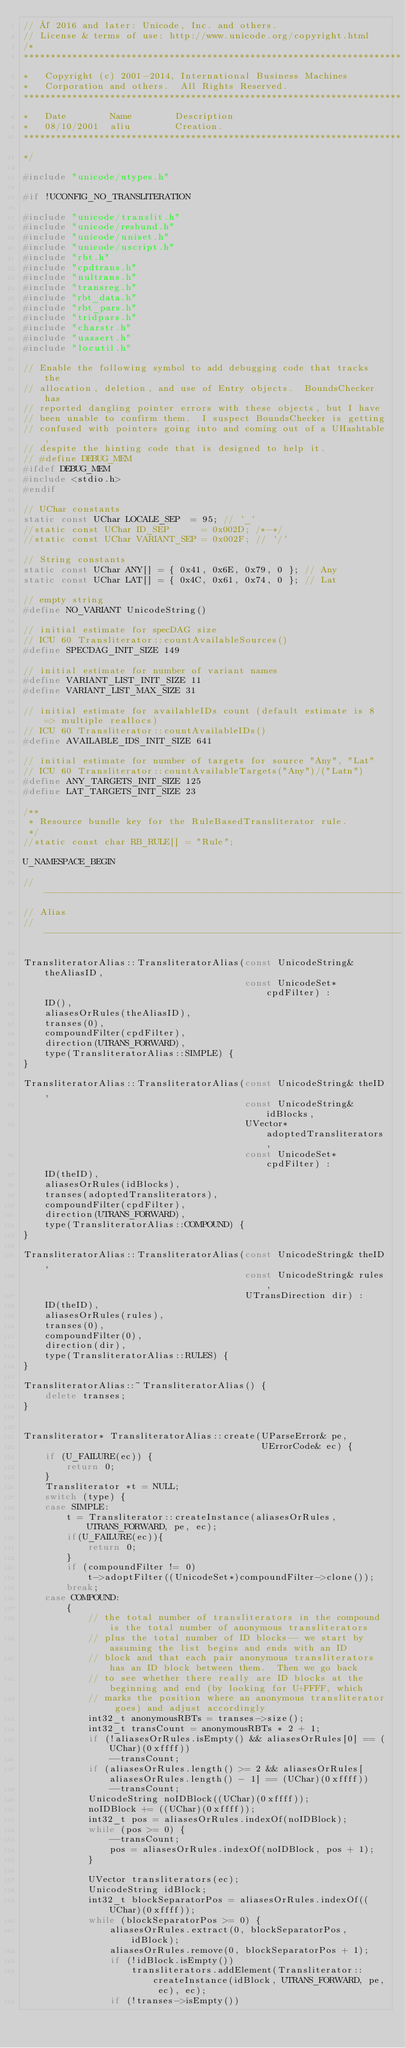Convert code to text. <code><loc_0><loc_0><loc_500><loc_500><_C++_>// © 2016 and later: Unicode, Inc. and others.
// License & terms of use: http://www.unicode.org/copyright.html
/*
**********************************************************************
*   Copyright (c) 2001-2014, International Business Machines
*   Corporation and others.  All Rights Reserved.
**********************************************************************
*   Date        Name        Description
*   08/10/2001  aliu        Creation.
**********************************************************************
*/

#include "unicode/utypes.h"

#if !UCONFIG_NO_TRANSLITERATION

#include "unicode/translit.h"
#include "unicode/resbund.h"
#include "unicode/uniset.h"
#include "unicode/uscript.h"
#include "rbt.h"
#include "cpdtrans.h"
#include "nultrans.h"
#include "transreg.h"
#include "rbt_data.h"
#include "rbt_pars.h"
#include "tridpars.h"
#include "charstr.h"
#include "uassert.h"
#include "locutil.h"

// Enable the following symbol to add debugging code that tracks the
// allocation, deletion, and use of Entry objects.  BoundsChecker has
// reported dangling pointer errors with these objects, but I have
// been unable to confirm them.  I suspect BoundsChecker is getting
// confused with pointers going into and coming out of a UHashtable,
// despite the hinting code that is designed to help it.
// #define DEBUG_MEM
#ifdef DEBUG_MEM
#include <stdio.h>
#endif

// UChar constants
static const UChar LOCALE_SEP  = 95; // '_'
//static const UChar ID_SEP      = 0x002D; /*-*/
//static const UChar VARIANT_SEP = 0x002F; // '/'

// String constants
static const UChar ANY[] = { 0x41, 0x6E, 0x79, 0 }; // Any
static const UChar LAT[] = { 0x4C, 0x61, 0x74, 0 }; // Lat

// empty string
#define NO_VARIANT UnicodeString()

// initial estimate for specDAG size
// ICU 60 Transliterator::countAvailableSources()
#define SPECDAG_INIT_SIZE 149

// initial estimate for number of variant names
#define VARIANT_LIST_INIT_SIZE 11
#define VARIANT_LIST_MAX_SIZE 31

// initial estimate for availableIDs count (default estimate is 8 => multiple reallocs)
// ICU 60 Transliterator::countAvailableIDs()
#define AVAILABLE_IDS_INIT_SIZE 641

// initial estimate for number of targets for source "Any", "Lat"
// ICU 60 Transliterator::countAvailableTargets("Any")/("Latn")
#define ANY_TARGETS_INIT_SIZE 125
#define LAT_TARGETS_INIT_SIZE 23

/**
 * Resource bundle key for the RuleBasedTransliterator rule.
 */
//static const char RB_RULE[] = "Rule";

U_NAMESPACE_BEGIN

//------------------------------------------------------------------
// Alias
//------------------------------------------------------------------

TransliteratorAlias::TransliteratorAlias(const UnicodeString& theAliasID,
                                         const UnicodeSet* cpdFilter) :
    ID(),
    aliasesOrRules(theAliasID),
    transes(0),
    compoundFilter(cpdFilter),
    direction(UTRANS_FORWARD),
    type(TransliteratorAlias::SIMPLE) {
}

TransliteratorAlias::TransliteratorAlias(const UnicodeString& theID,
                                         const UnicodeString& idBlocks,
                                         UVector* adoptedTransliterators,
                                         const UnicodeSet* cpdFilter) :
    ID(theID),
    aliasesOrRules(idBlocks),
    transes(adoptedTransliterators),
    compoundFilter(cpdFilter),
    direction(UTRANS_FORWARD),
    type(TransliteratorAlias::COMPOUND) {
}

TransliteratorAlias::TransliteratorAlias(const UnicodeString& theID,
                                         const UnicodeString& rules,
                                         UTransDirection dir) :
    ID(theID),
    aliasesOrRules(rules),
    transes(0),
    compoundFilter(0),
    direction(dir),
    type(TransliteratorAlias::RULES) {
}

TransliteratorAlias::~TransliteratorAlias() {
    delete transes;
}


Transliterator* TransliteratorAlias::create(UParseError& pe,
                                            UErrorCode& ec) {
    if (U_FAILURE(ec)) {
        return 0;
    }
    Transliterator *t = NULL;
    switch (type) {
    case SIMPLE:
        t = Transliterator::createInstance(aliasesOrRules, UTRANS_FORWARD, pe, ec);
        if(U_FAILURE(ec)){
            return 0;
        }
        if (compoundFilter != 0)
            t->adoptFilter((UnicodeSet*)compoundFilter->clone());
        break;
    case COMPOUND:
        {
            // the total number of transliterators in the compound is the total number of anonymous transliterators
            // plus the total number of ID blocks-- we start by assuming the list begins and ends with an ID
            // block and that each pair anonymous transliterators has an ID block between them.  Then we go back
            // to see whether there really are ID blocks at the beginning and end (by looking for U+FFFF, which
            // marks the position where an anonymous transliterator goes) and adjust accordingly
            int32_t anonymousRBTs = transes->size();
            int32_t transCount = anonymousRBTs * 2 + 1;
            if (!aliasesOrRules.isEmpty() && aliasesOrRules[0] == (UChar)(0xffff))
                --transCount;
            if (aliasesOrRules.length() >= 2 && aliasesOrRules[aliasesOrRules.length() - 1] == (UChar)(0xffff))
                --transCount;
            UnicodeString noIDBlock((UChar)(0xffff));
            noIDBlock += ((UChar)(0xffff));
            int32_t pos = aliasesOrRules.indexOf(noIDBlock);
            while (pos >= 0) {
                --transCount;
                pos = aliasesOrRules.indexOf(noIDBlock, pos + 1);
            }

            UVector transliterators(ec);
            UnicodeString idBlock;
            int32_t blockSeparatorPos = aliasesOrRules.indexOf((UChar)(0xffff));
            while (blockSeparatorPos >= 0) {
                aliasesOrRules.extract(0, blockSeparatorPos, idBlock);
                aliasesOrRules.remove(0, blockSeparatorPos + 1);
                if (!idBlock.isEmpty())
                    transliterators.addElement(Transliterator::createInstance(idBlock, UTRANS_FORWARD, pe, ec), ec);
                if (!transes->isEmpty())</code> 